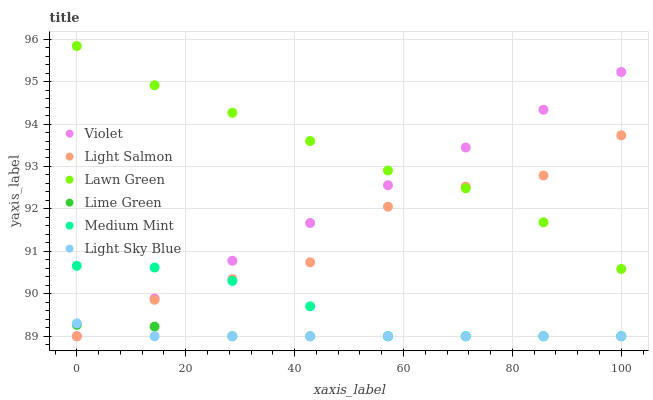Does Light Sky Blue have the minimum area under the curve?
Answer yes or no. Yes. Does Lawn Green have the maximum area under the curve?
Answer yes or no. Yes. Does Light Salmon have the minimum area under the curve?
Answer yes or no. No. Does Light Salmon have the maximum area under the curve?
Answer yes or no. No. Is Violet the smoothest?
Answer yes or no. Yes. Is Light Salmon the roughest?
Answer yes or no. Yes. Is Lawn Green the smoothest?
Answer yes or no. No. Is Lawn Green the roughest?
Answer yes or no. No. Does Medium Mint have the lowest value?
Answer yes or no. Yes. Does Lawn Green have the lowest value?
Answer yes or no. No. Does Lawn Green have the highest value?
Answer yes or no. Yes. Does Light Salmon have the highest value?
Answer yes or no. No. Is Medium Mint less than Lawn Green?
Answer yes or no. Yes. Is Lawn Green greater than Lime Green?
Answer yes or no. Yes. Does Light Sky Blue intersect Lime Green?
Answer yes or no. Yes. Is Light Sky Blue less than Lime Green?
Answer yes or no. No. Is Light Sky Blue greater than Lime Green?
Answer yes or no. No. Does Medium Mint intersect Lawn Green?
Answer yes or no. No. 